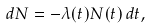<formula> <loc_0><loc_0><loc_500><loc_500>d N = - \lambda ( t ) N ( t ) \, d t ,</formula> 